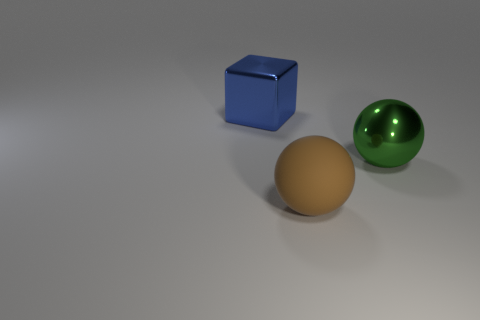Are there an equal number of blue shiny objects in front of the large green metal ball and brown matte balls in front of the big blue cube? No, there is not an equal number of blue shiny objects in front of the large green metal ball as there are brown matte balls in front of the big blue cube. In the image, there is one blue shiny cube and no brown matte balls present at all. 